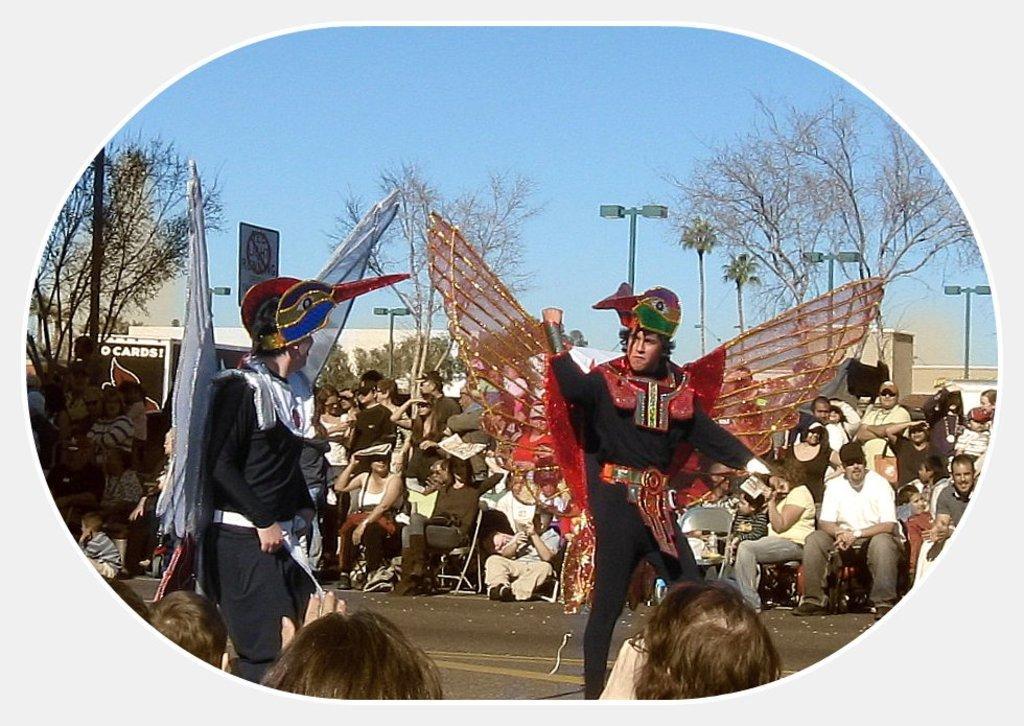In one or two sentences, can you explain what this image depicts? In this image I can see group of people are sitting on chairs. Here I can see two persons are standing and wearing costumes. In the background I can see trees and the sky. 